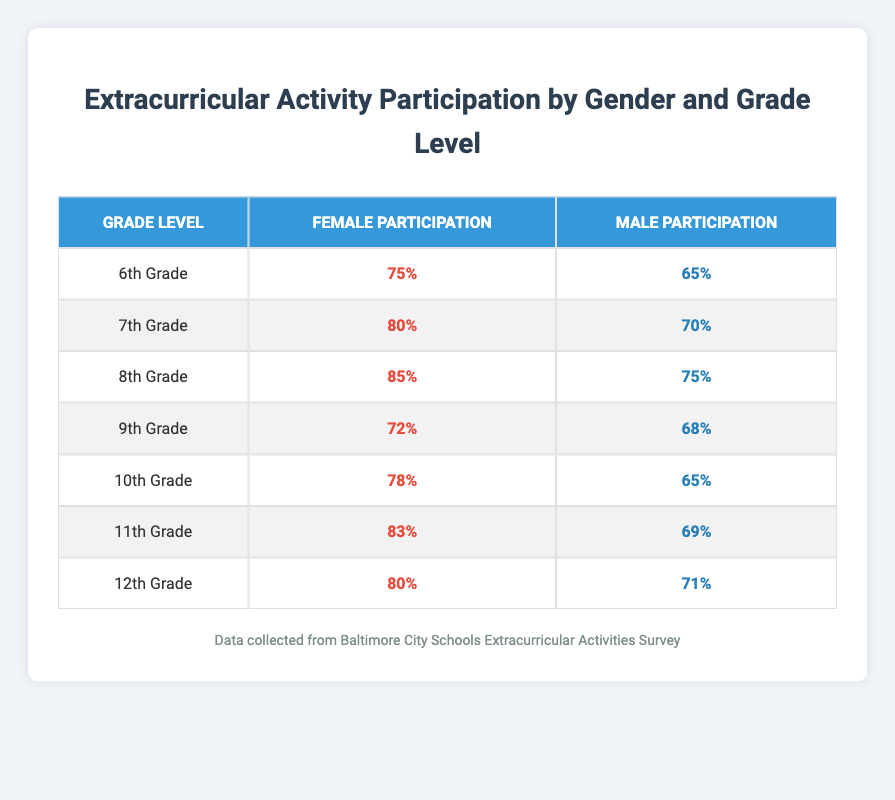What is the participation rate for females in 10th Grade? Referring to the table, under 10th Grade, the Female Participation Rate is listed as 78%.
Answer: 78% What is the difference in participation rates between males and females in 7th Grade? In 7th Grade, the Female Participation Rate is 80% and the Male Participation Rate is 70%. The difference is 80% - 70% = 10%.
Answer: 10% Do more females participate in extracurricular activities than males in 12th Grade? The Female Participation Rate for 12th Grade is 80% and the Male Participation Rate is 71%. Since 80% is greater than 71%, the answer is yes.
Answer: Yes What is the average participation rate for males across all grade levels? The Male Participation Rates for each grade level are 65%, 70%, 75%, 68%, 65%, 69%, and 71%. The total is (65 + 70 + 75 + 68 + 65 + 69 + 71) = 479. There are 7 grade levels, so the average is 479 / 7 ≈ 68.43%.
Answer: 68.43% For which grade level is the participation rate for females the highest? Reviewing the data, the highest Female Participation Rate is 85%, which occurs in 8th Grade.
Answer: 8th Grade What is the participation rate for males in 11th Grade? In the table, under 11th Grade, the Male Participation Rate is noted as 69%.
Answer: 69% Are the female participation rates in 6th Grade higher than those in 9th Grade? The Female Participation Rate in 6th Grade is 75% while in 9th Grade it is 72%. Since 75% is greater than 72%, the answer is yes.
Answer: Yes Which gender has a higher participation rate in 8th Grade and what is that rate? In 8th Grade, the Female Participation Rate is 85%, and the Male Participation Rate is 75%. Since 85% is higher, females have the higher participation rate.
Answer: Females, 85% 